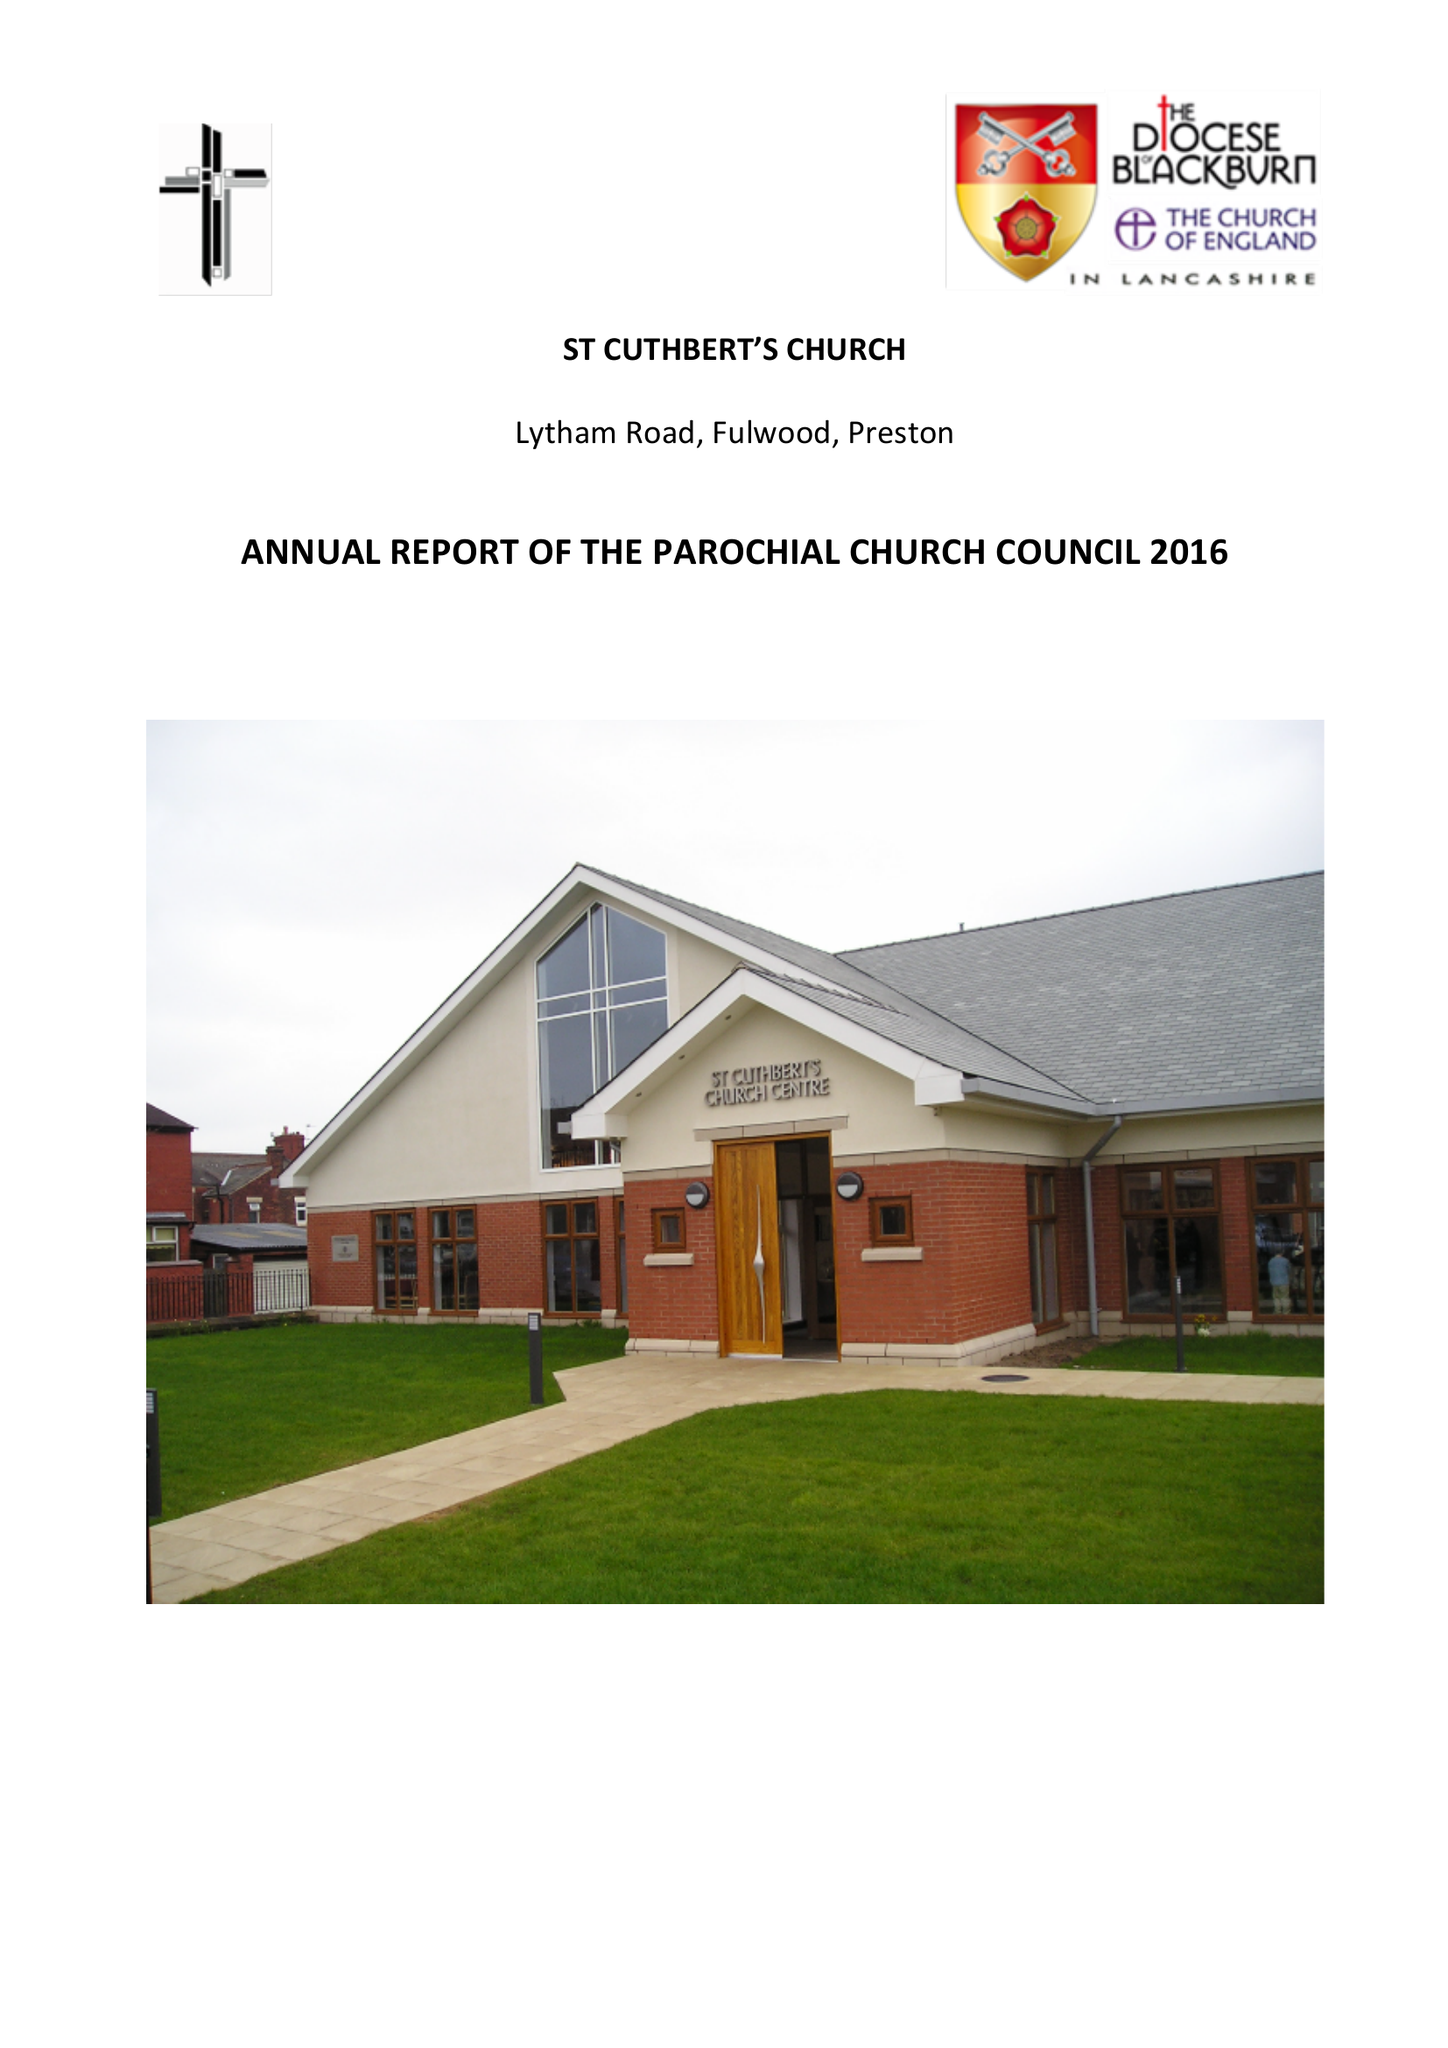What is the value for the address__postcode?
Answer the question using a single word or phrase. PR2 3AP 